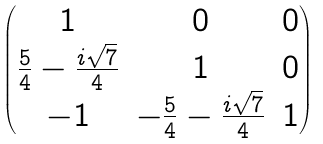Convert formula to latex. <formula><loc_0><loc_0><loc_500><loc_500>\begin{pmatrix} 1 & 0 & 0 \\ \frac { 5 } { 4 } - \frac { i \sqrt { 7 } } { 4 } & 1 & 0 \\ - 1 & - \frac { 5 } { 4 } - \frac { i \sqrt { 7 } } { 4 } & 1 \end{pmatrix}</formula> 